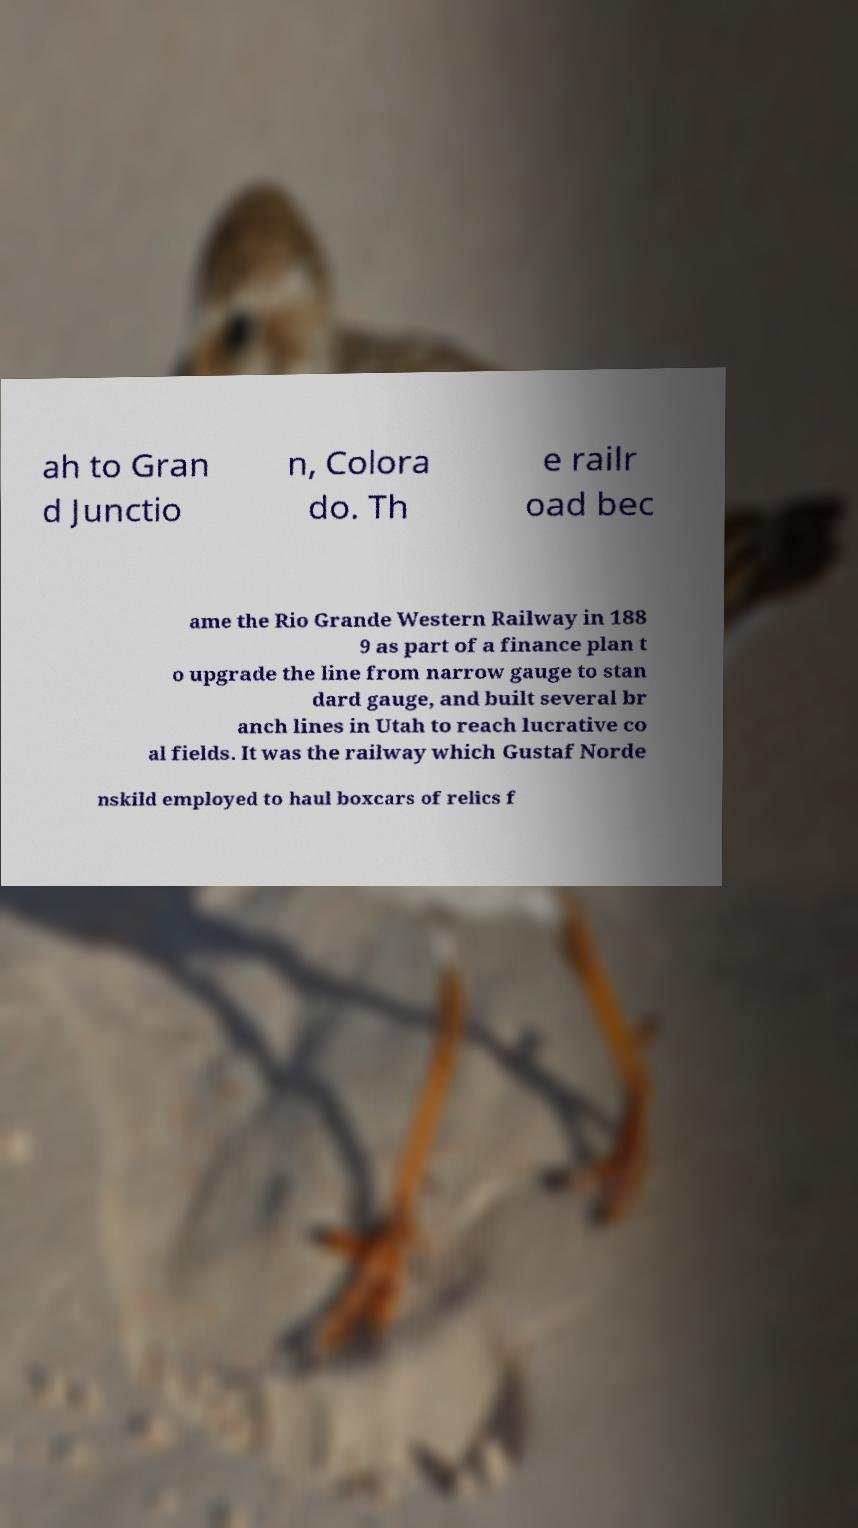What messages or text are displayed in this image? I need them in a readable, typed format. ah to Gran d Junctio n, Colora do. Th e railr oad bec ame the Rio Grande Western Railway in 188 9 as part of a finance plan t o upgrade the line from narrow gauge to stan dard gauge, and built several br anch lines in Utah to reach lucrative co al fields. It was the railway which Gustaf Norde nskild employed to haul boxcars of relics f 